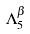<formula> <loc_0><loc_0><loc_500><loc_500>\Lambda _ { 5 } ^ { \beta }</formula> 